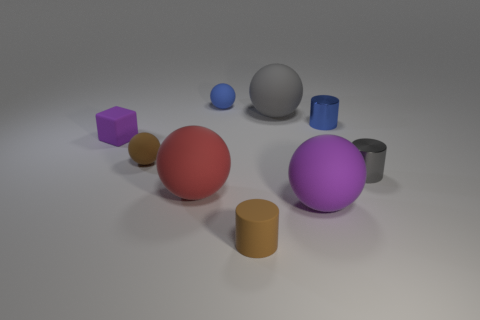Is the number of tiny brown things that are to the left of the small purple block greater than the number of red cylinders?
Offer a terse response. No. There is a brown thing behind the tiny brown matte thing in front of the tiny brown thing behind the large red object; what is it made of?
Your response must be concise. Rubber. How many things are either blue rubber balls or big things that are behind the red thing?
Provide a succinct answer. 2. There is a big matte thing that is to the left of the small brown rubber cylinder; is it the same color as the matte cylinder?
Keep it short and to the point. No. Are there more blue balls that are in front of the small blue shiny object than purple matte balls in front of the big purple thing?
Your response must be concise. No. Are there any other things of the same color as the small matte cylinder?
Offer a terse response. Yes. What number of things are either big gray rubber spheres or big rubber objects?
Ensure brevity in your answer.  3. There is a purple thing right of the purple matte block; is its size the same as the small gray object?
Your answer should be compact. No. How many other objects are the same size as the blue shiny cylinder?
Ensure brevity in your answer.  5. Are any tiny blue cubes visible?
Your answer should be compact. No. 